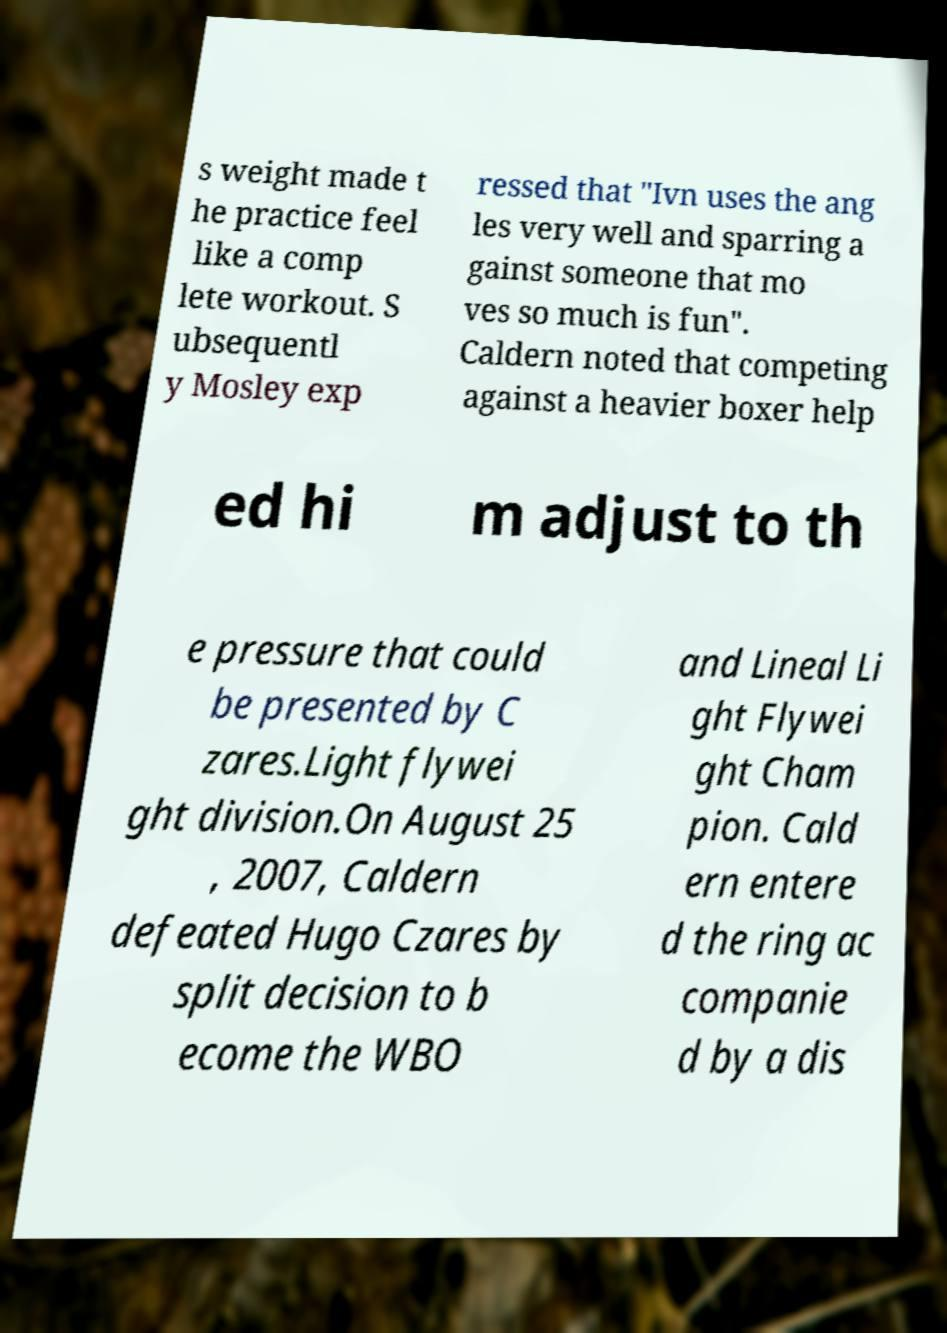Please identify and transcribe the text found in this image. s weight made t he practice feel like a comp lete workout. S ubsequentl y Mosley exp ressed that "Ivn uses the ang les very well and sparring a gainst someone that mo ves so much is fun". Caldern noted that competing against a heavier boxer help ed hi m adjust to th e pressure that could be presented by C zares.Light flywei ght division.On August 25 , 2007, Caldern defeated Hugo Czares by split decision to b ecome the WBO and Lineal Li ght Flywei ght Cham pion. Cald ern entere d the ring ac companie d by a dis 